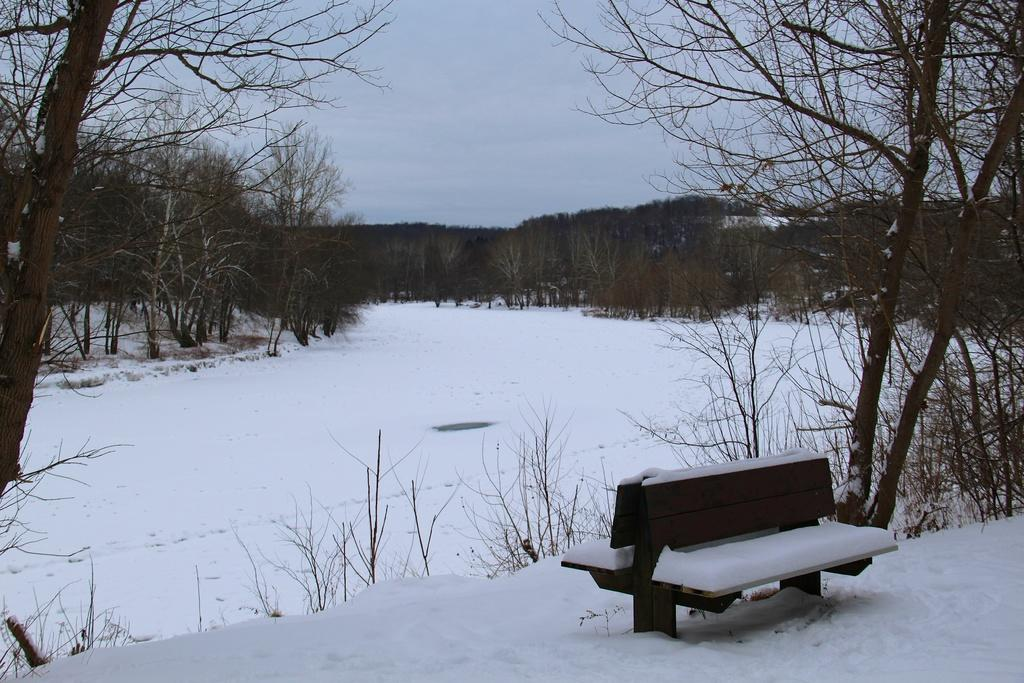What type of natural environment is depicted at the bottom of the image? There is snow at the bottom of the image. What type of seating is present in the image? There is a bench in the image. What can be seen in the background of the image? There are trees in the background of the image. What is visible at the top of the image? The sky is visible at the top of the image. What type of glue is being used by the girls in the image? There are no girls or glue present in the image. What type of meat is being served on the bench in the image? There is no meat present in the image; it features snow, a bench, trees, and sky. 